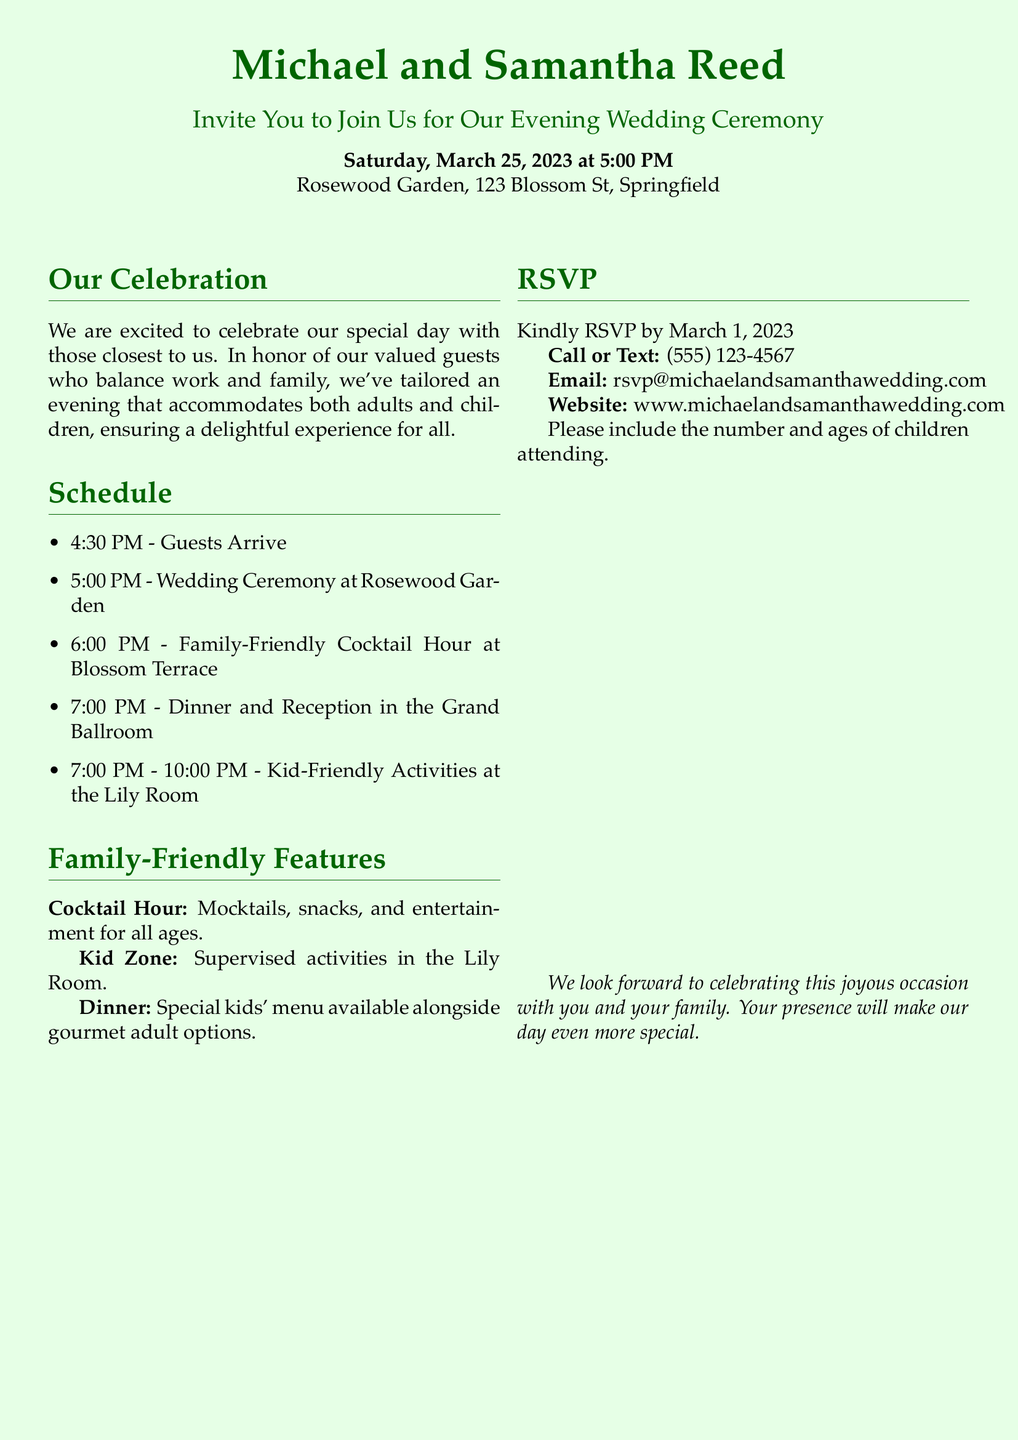What is the date of the wedding? The date of the wedding is specified in the invitation as Saturday, March 25, 2023.
Answer: March 25, 2023 What time does the wedding ceremony start? The wedding ceremony start time is provided in the schedule section of the invitation.
Answer: 5:00 PM Where is the wedding ceremony taking place? The location of the ceremony is mentioned at the beginning of the document.
Answer: Rosewood Garden What activities are planned for the children? The invitation outlines the kid-friendly activities in the dedicated section for family-friendly features.
Answer: Supervised activities in the Lily Room What is provided during the cocktail hour? The invitation describes the offerings during the cocktail hour.
Answer: Mocktails, snacks, and entertainment What is the RSVP deadline? The RSVP deadline is noted in the RSVP section of the invitation.
Answer: March 1, 2023 What is the contact method for RSVPs? The invitation specifies various ways to contact for RSVPs.
Answer: Call or Text: (555) 123-4567 What type of menu will be available during dinner? The invitation mentions the type of dinner menu offered for guests.
Answer: Special kids' menu available alongside gourmet adult options How is the wedding designed to accommodate working parents? The document details how the schedule is tailored for convenience for adults and children, ensuring all can enjoy.
Answer: Tailored an evening that accommodates both adults and children 